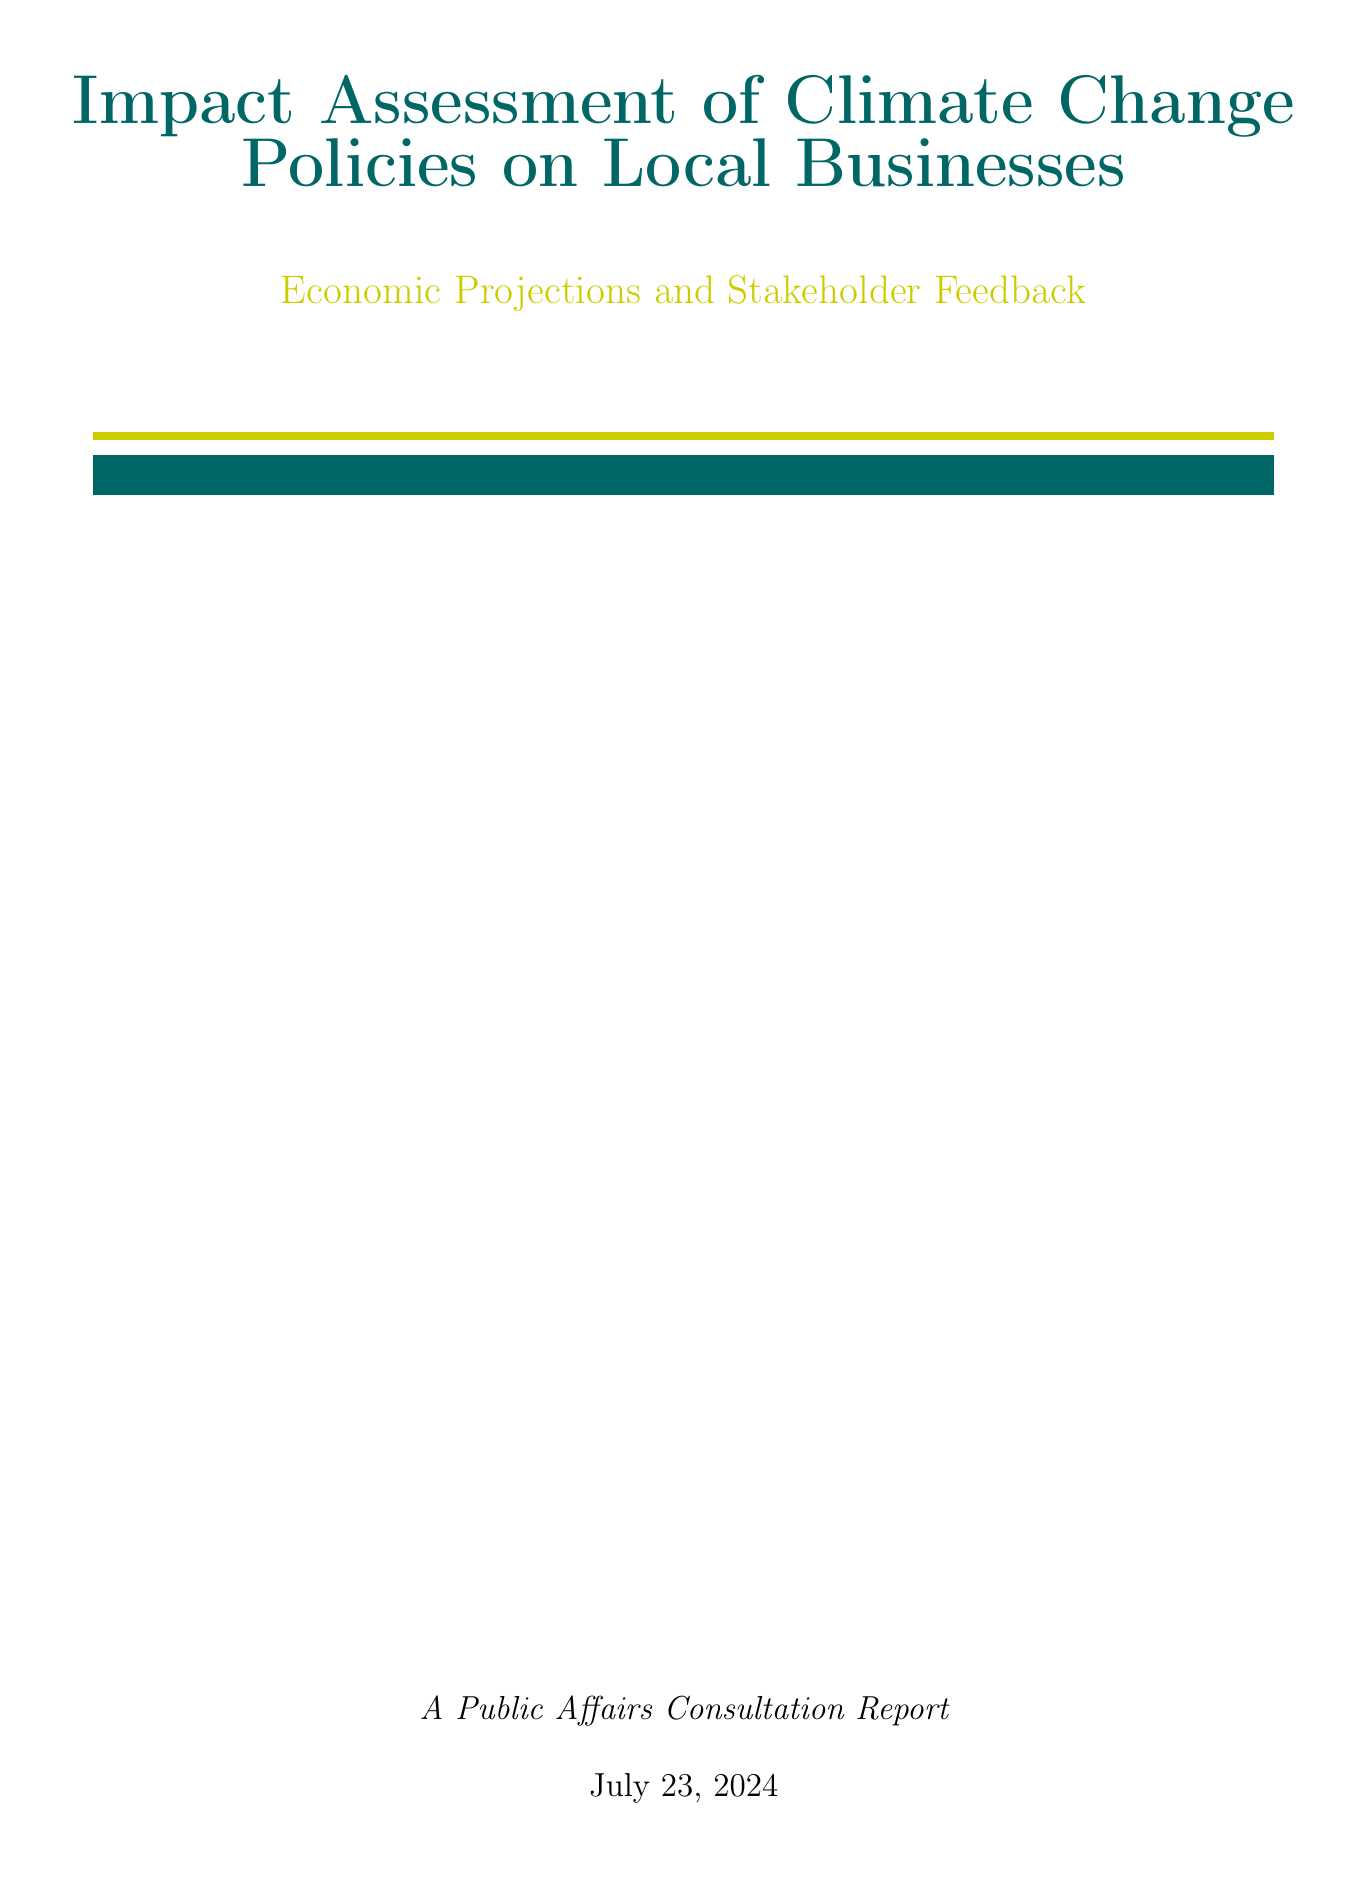what is the title of the report? The title of the report is provided in the document's title section.
Answer: Impact Assessment of Climate Change Policies on Local Businesses: Economic Projections and Stakeholder Feedback what year did the UK become the first major economy to pass a net zero emissions law? The document includes a timeline of significant events related to climate change policies, including this specific year.
Answer: 2019 what is one of the key points from the executive summary? The executive summary lists major points summarizing the report's content, such as economic projections and stakeholder feedback.
Answer: Economic projections for the next 5-10 years what is the implementation year of the Greater Manchester Clean Air Plan? This information is found under the local policies section, where implementation years are detailed for each policy.
Answer: 2022 what is the projected long-term reduction in carbon emissions from local businesses? The economic projections section provides exact figures for anticipated metrics regarding emissions reductions.
Answer: 15% what kind of feedback did the Greater Manchester Chamber of Commerce provide? Feedback from specific business associations is summarized in the stakeholder feedback section.
Answer: Concerns about short-term costs, but recognition of long-term benefits which company had positive growth due to increased demand for wind turbine production? Case studies within the document provide examples of companies impacted by climate policies and their respective outcomes.
Answer: Siemens Gamesa what is one recommended action from the conclusion and next steps? The report recommends several actions aimed at addressing climate change. This specific type of question addresses the content of the recommendation section.
Answer: Establish a Greater Manchester Business Climate Adaptation Task Force 